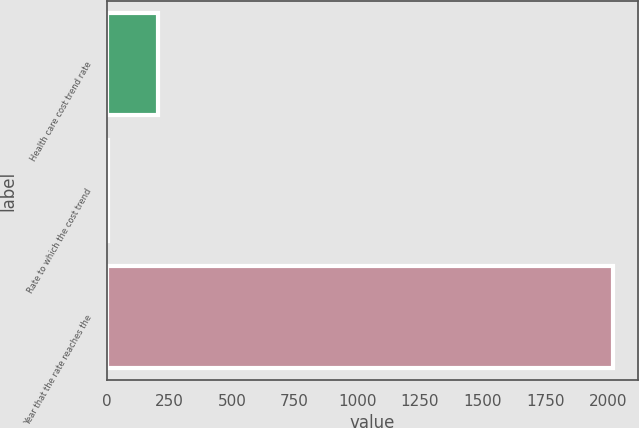<chart> <loc_0><loc_0><loc_500><loc_500><bar_chart><fcel>Health care cost trend rate<fcel>Rate to which the cost trend<fcel>Year that the rate reaches the<nl><fcel>206.3<fcel>5<fcel>2018<nl></chart> 